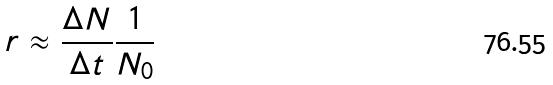Convert formula to latex. <formula><loc_0><loc_0><loc_500><loc_500>r \approx \frac { \Delta N } { \Delta t } \frac { 1 } { N _ { 0 } }</formula> 